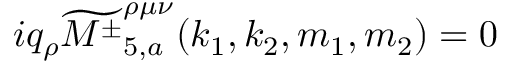Convert formula to latex. <formula><loc_0><loc_0><loc_500><loc_500>i q _ { \rho } \widetilde { { M ^ { \pm } } } _ { 5 , a } ^ { \rho \mu \nu } ( k _ { 1 } , k _ { 2 } , m _ { 1 } , m _ { 2 } ) = 0</formula> 